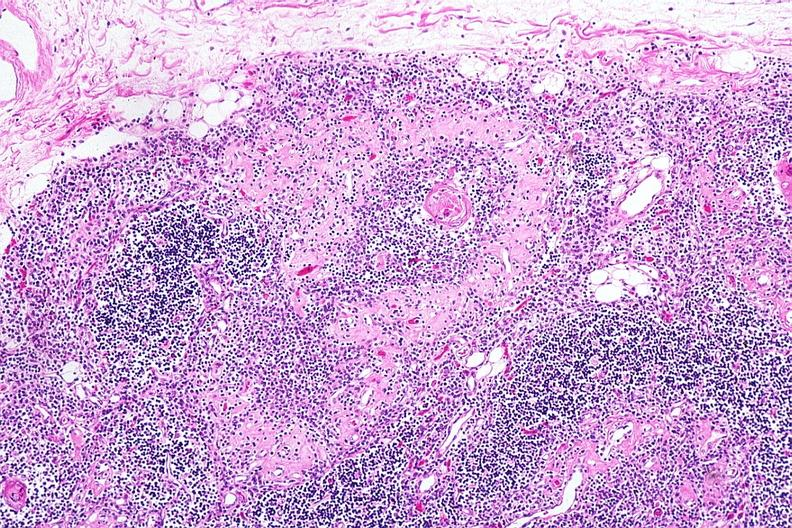s metastatic carcinoma colon present?
Answer the question using a single word or phrase. No 